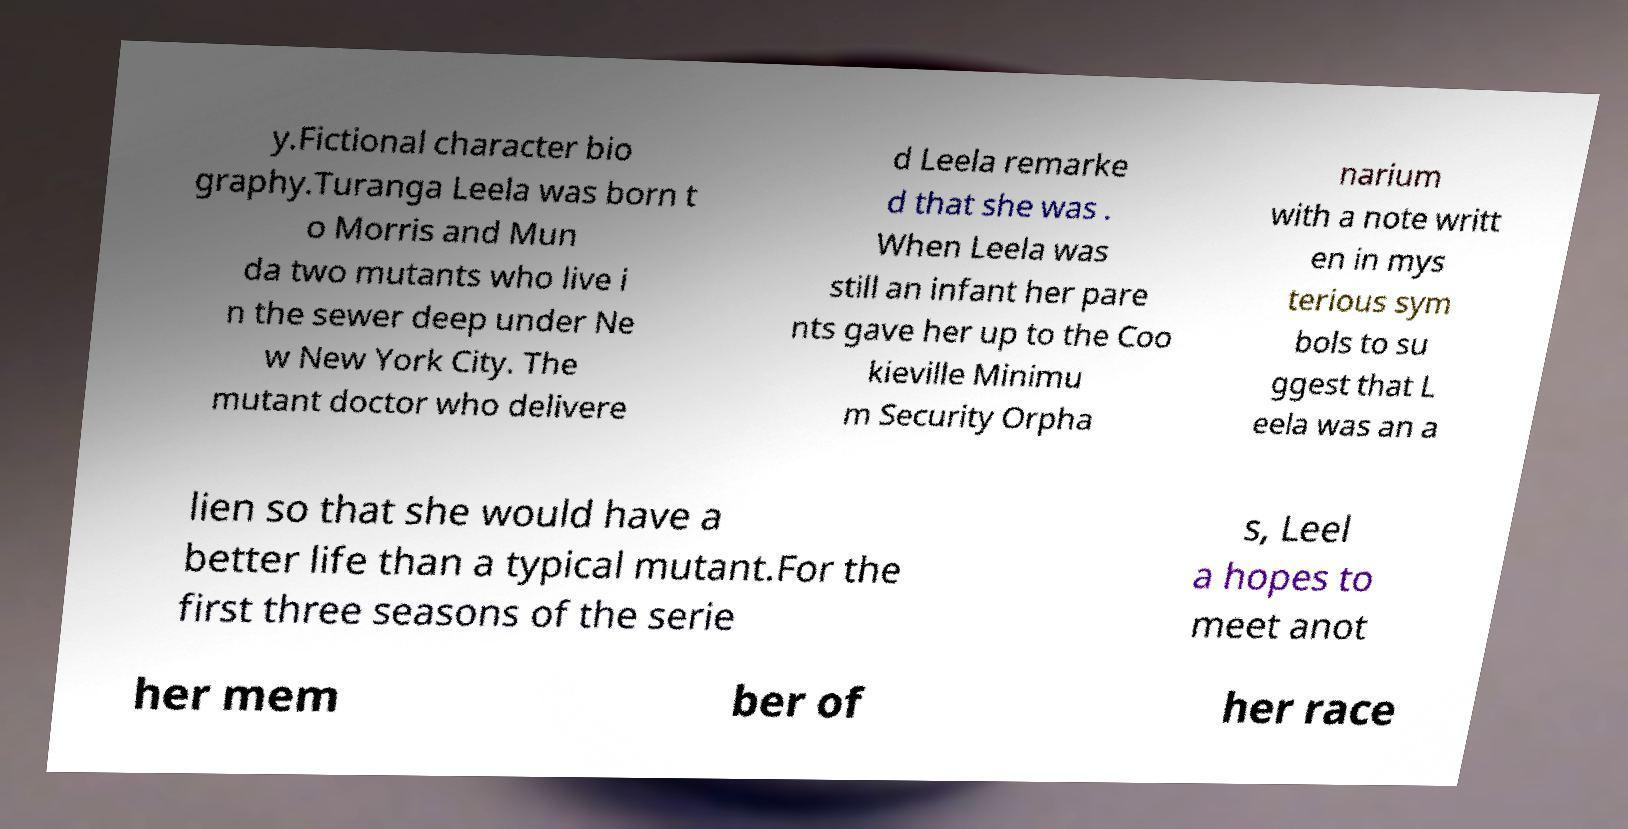Please read and relay the text visible in this image. What does it say? y.Fictional character bio graphy.Turanga Leela was born t o Morris and Mun da two mutants who live i n the sewer deep under Ne w New York City. The mutant doctor who delivere d Leela remarke d that she was . When Leela was still an infant her pare nts gave her up to the Coo kieville Minimu m Security Orpha narium with a note writt en in mys terious sym bols to su ggest that L eela was an a lien so that she would have a better life than a typical mutant.For the first three seasons of the serie s, Leel a hopes to meet anot her mem ber of her race 